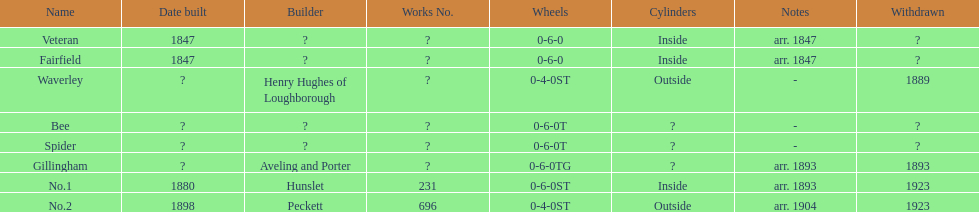Other than fairfield, what else was built in 1847? Veteran. 